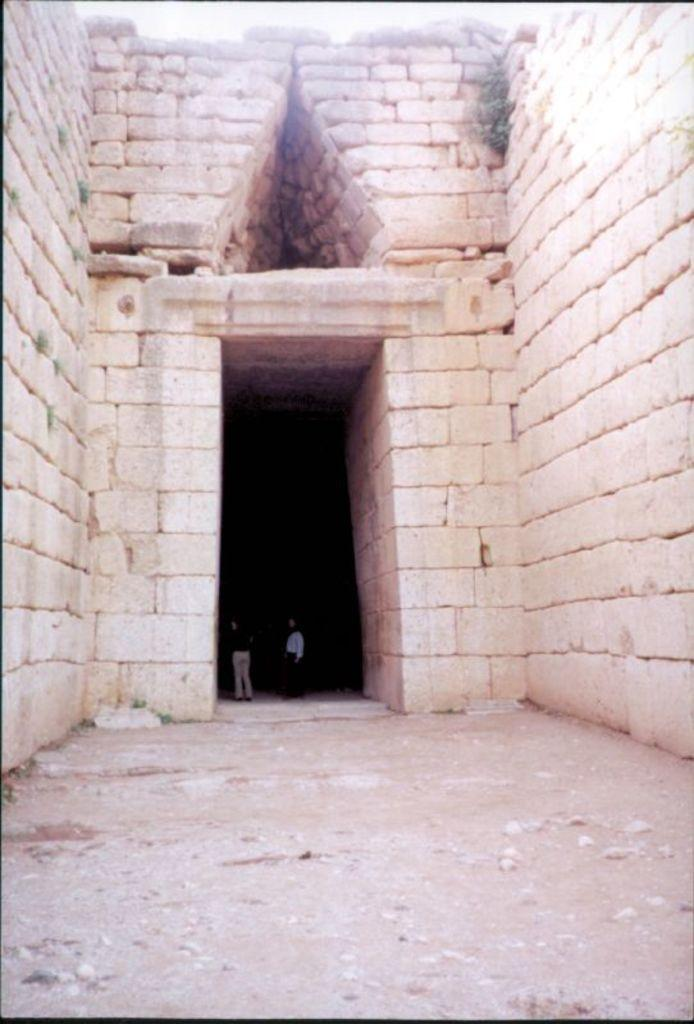What is the main subject of the image? There is a monument in the image. What material is the monument made of? The monument is made up of bricks. How far away is the rat from the monument in the image? There is no rat present in the image, so it cannot be determined how far away it might be from the monument. 